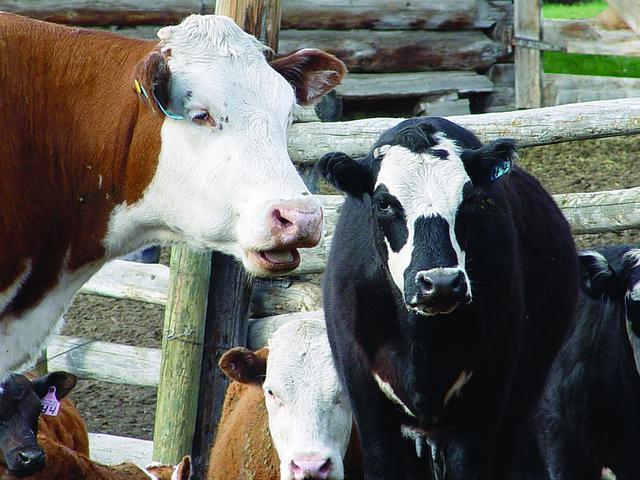Who put the tag on the cows ear?
From the following four choices, select the correct answer to address the question.
Options: Another cow, dog, human, alien. Human. 